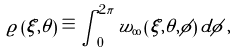Convert formula to latex. <formula><loc_0><loc_0><loc_500><loc_500>\varrho \left ( \xi , \theta \right ) \equiv \int _ { 0 } ^ { 2 \pi } w _ { \infty } \left ( \xi , \theta , \phi \right ) d \phi \, ,</formula> 